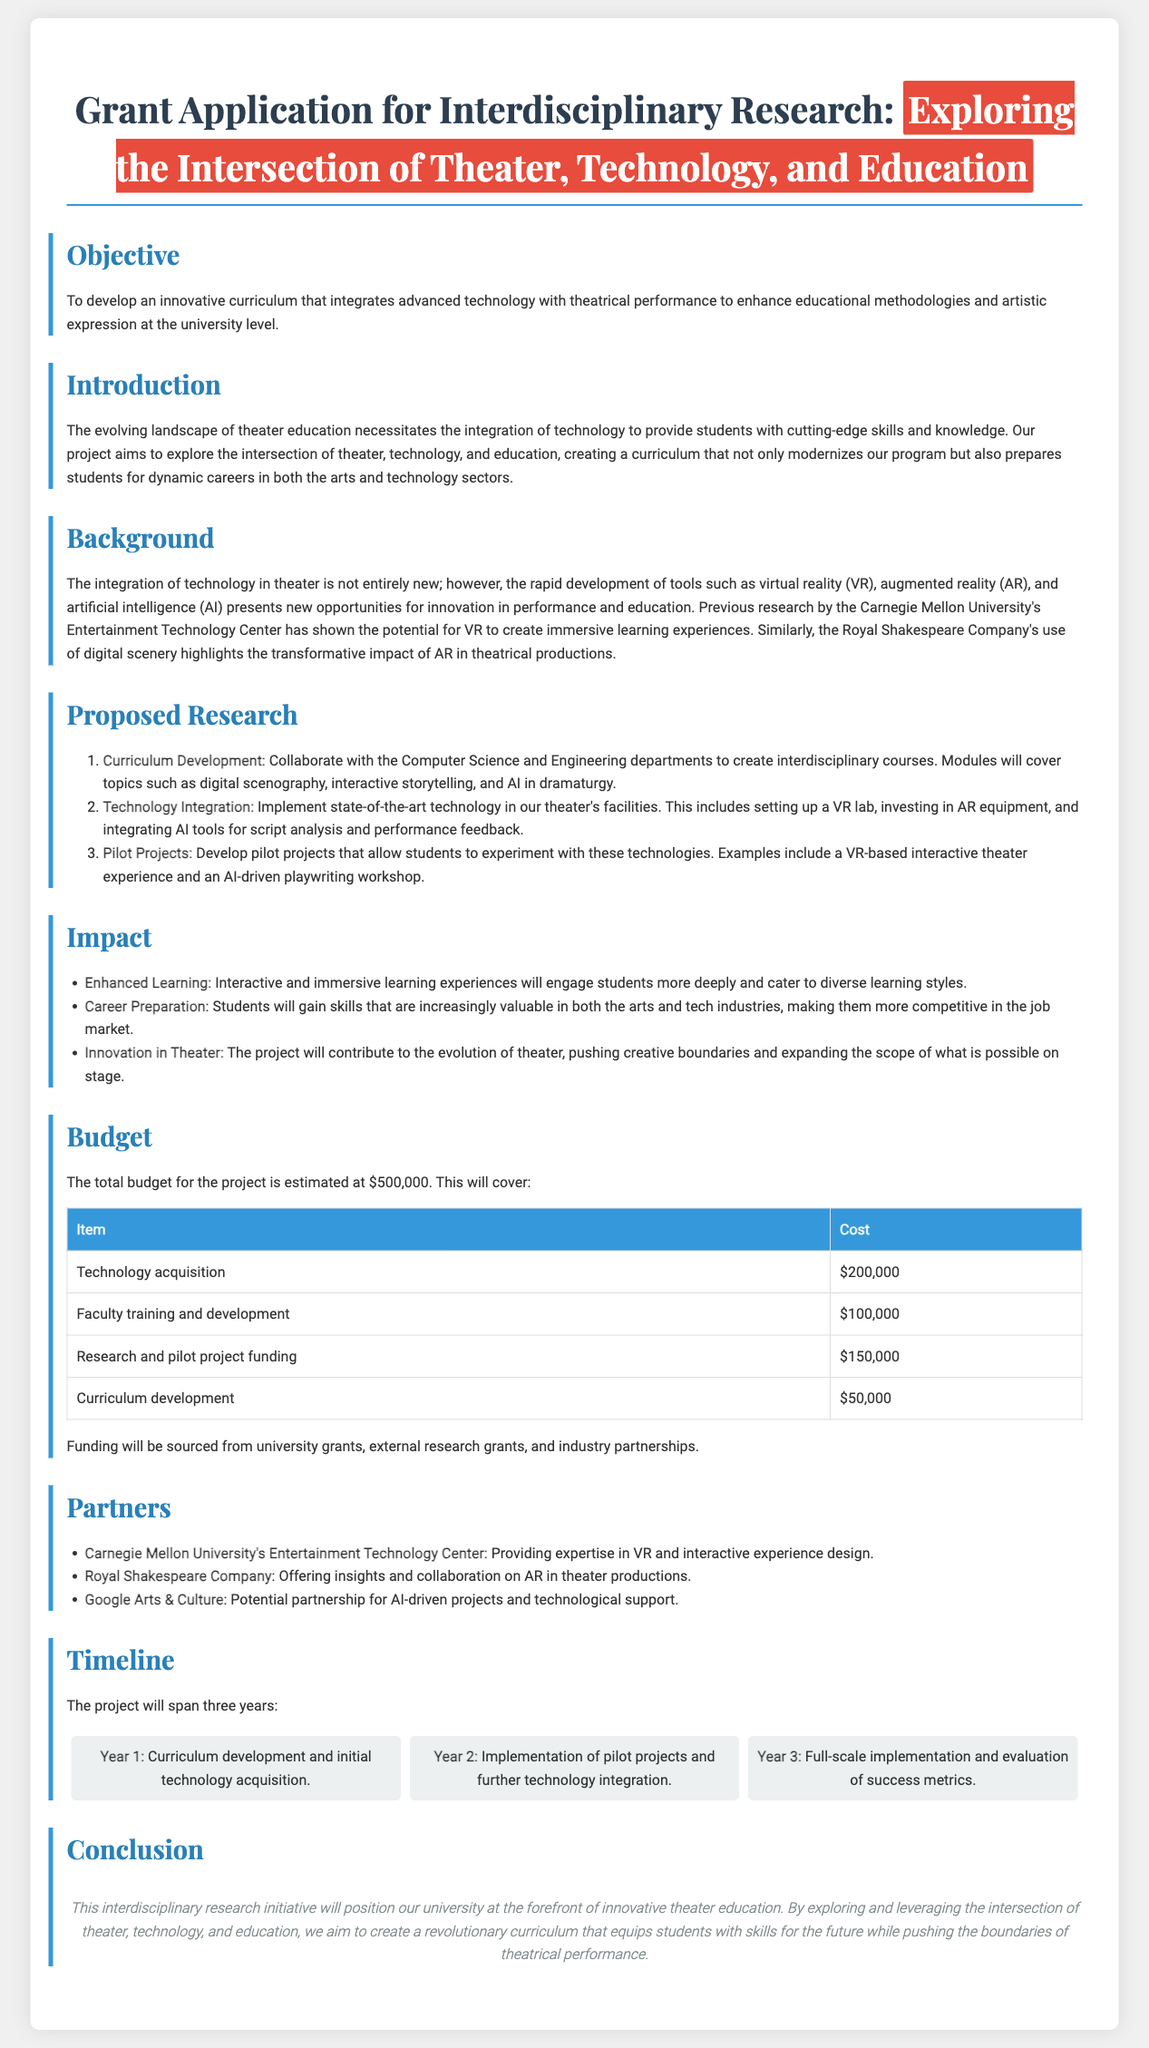What is the main objective of the grant application? The objective of the grant application is to develop an innovative curriculum that integrates advanced technology with theatrical performance.
Answer: To develop an innovative curriculum that integrates advanced technology with theatrical performance What is the estimated total budget for the project? The total budget is stated explicitly in the document as $500,000.
Answer: $500,000 Which department will collaborate on curriculum development? The document mentions collaboration with the Computer Science and Engineering departments for creating interdisciplinary courses.
Answer: Computer Science and Engineering What technology is proposed for acquisition in the budget? The budget outlines the acquisition of technology, including VR and AR equipment.
Answer: Technology acquisition How long will the project span? The timeline section indicates that the project will span three years.
Answer: Three years What is one of the anticipated impacts of the project? The document lists several impacts, one of which is providing students with skills that are increasingly valuable in the arts and tech industries.
Answer: Career Preparation What type of projects will be developed for students to experiment with? The proposed research includes developing pilot projects for students, specifically mentioning a VR-based interactive theater experience.
Answer: VR-based interactive theater experience Who is a partner that offers expertise in VR? The document lists Carnegie Mellon University's Entertainment Technology Center as a partner providing expertise in VR and interactive experience design.
Answer: Carnegie Mellon University's Entertainment Technology Center What is the conclusion of the document? The conclusion highlights the goal to create a revolutionary curriculum that equips students with skills for the future while pushing the boundaries of theatrical performance.
Answer: This interdisciplinary research initiative will position our university at the forefront of innovative theater education 